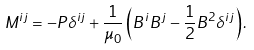<formula> <loc_0><loc_0><loc_500><loc_500>M ^ { i j } = - P \delta ^ { i j } + \frac { 1 } { \mu _ { 0 } } \left ( B ^ { i } B ^ { j } - \frac { 1 } { 2 } B ^ { 2 } \delta ^ { i j } \right ) .</formula> 